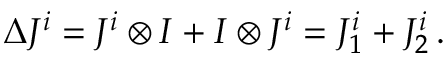<formula> <loc_0><loc_0><loc_500><loc_500>\Delta J ^ { i } = J ^ { i } \otimes I + I \otimes J ^ { i } = J _ { 1 } ^ { i } + J _ { 2 } ^ { i } \, .</formula> 